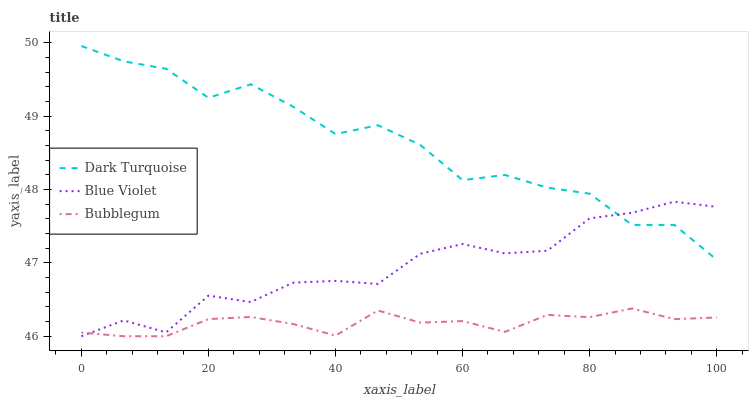Does Bubblegum have the minimum area under the curve?
Answer yes or no. Yes. Does Dark Turquoise have the maximum area under the curve?
Answer yes or no. Yes. Does Blue Violet have the minimum area under the curve?
Answer yes or no. No. Does Blue Violet have the maximum area under the curve?
Answer yes or no. No. Is Bubblegum the smoothest?
Answer yes or no. Yes. Is Dark Turquoise the roughest?
Answer yes or no. Yes. Is Blue Violet the smoothest?
Answer yes or no. No. Is Blue Violet the roughest?
Answer yes or no. No. Does Bubblegum have the lowest value?
Answer yes or no. Yes. Does Dark Turquoise have the highest value?
Answer yes or no. Yes. Does Blue Violet have the highest value?
Answer yes or no. No. Is Bubblegum less than Dark Turquoise?
Answer yes or no. Yes. Is Dark Turquoise greater than Bubblegum?
Answer yes or no. Yes. Does Dark Turquoise intersect Blue Violet?
Answer yes or no. Yes. Is Dark Turquoise less than Blue Violet?
Answer yes or no. No. Is Dark Turquoise greater than Blue Violet?
Answer yes or no. No. Does Bubblegum intersect Dark Turquoise?
Answer yes or no. No. 